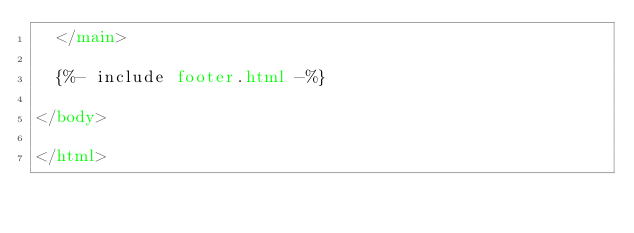Convert code to text. <code><loc_0><loc_0><loc_500><loc_500><_HTML_>  </main>

  {%- include footer.html -%}

</body>

</html>
</code> 